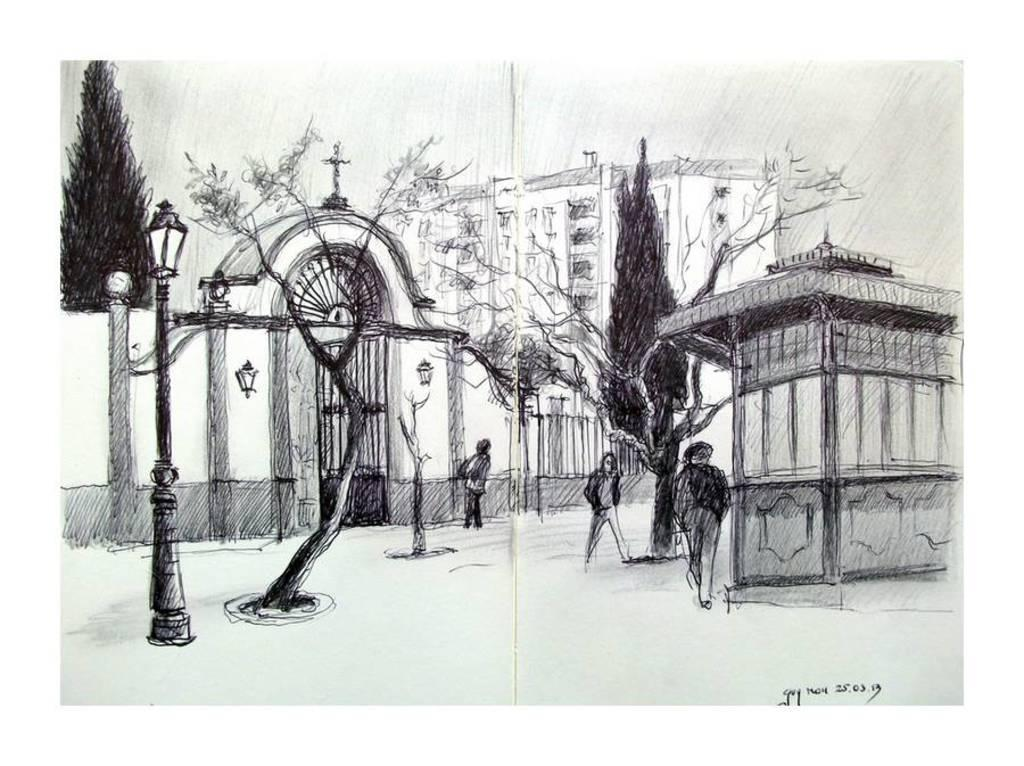What type of artwork is featured in the image? The image contains a sketch. Can you describe the subjects in the sketch? There are persons standing in the image. What other objects or structures can be seen in the image? There are light poles, trees, and buildings in the image. What is the color scheme of the image? The image is in black and white. How many flocks of beef are visible in the image? There are no flocks of beef present in the image, as it features a sketch with persons, light poles, trees, and buildings. What causes the burst of colors in the image? There is no burst of colors in the image, as it is in black and white. 